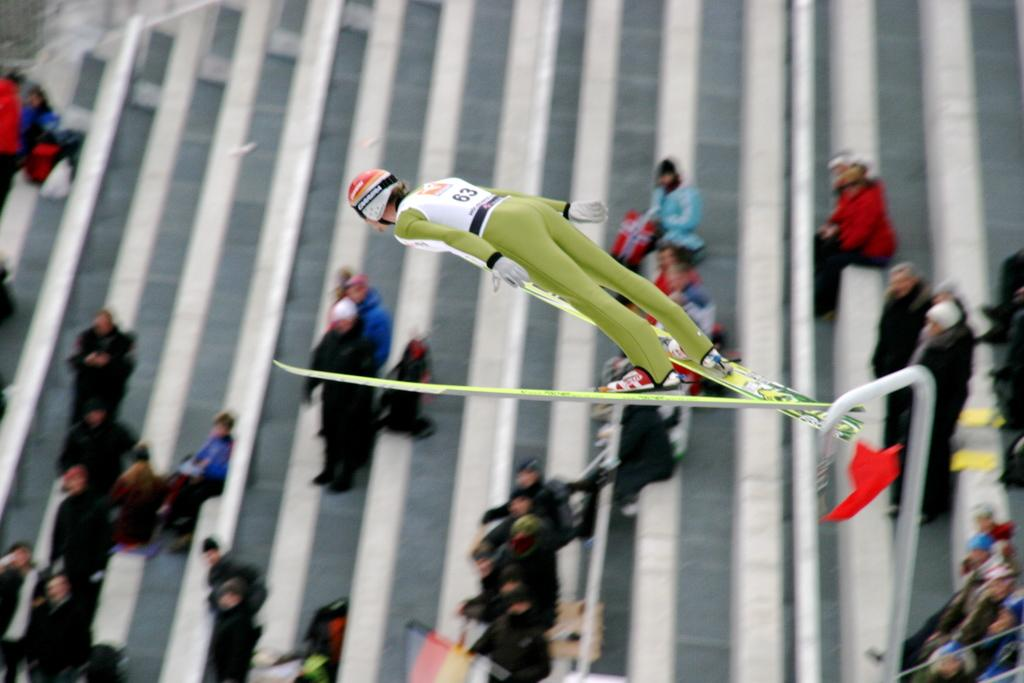What is the main subject of the image? The main subject of the image is a man. What is the man doing in the image? The man is doing a jumping action in the image. Are there any other people visible in the image? Yes, there are people standing and sitting behind the man. What type of advertisement is being displayed on the man's shirt in the image? There is no advertisement visible on the man's shirt in the image. What organization is the man representing in the image? There is no indication of any organization in the image. 